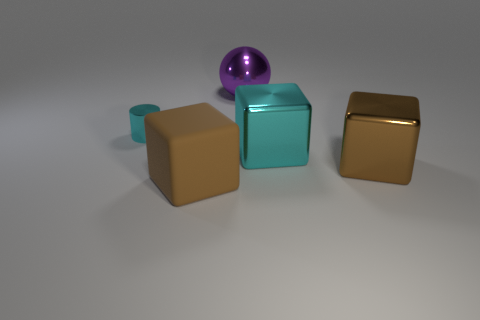Add 2 purple things. How many objects exist? 7 Subtract all blocks. How many objects are left? 2 Subtract 0 brown balls. How many objects are left? 5 Subtract all big metal spheres. Subtract all small matte cylinders. How many objects are left? 4 Add 4 metal things. How many metal things are left? 8 Add 3 big brown metallic objects. How many big brown metallic objects exist? 4 